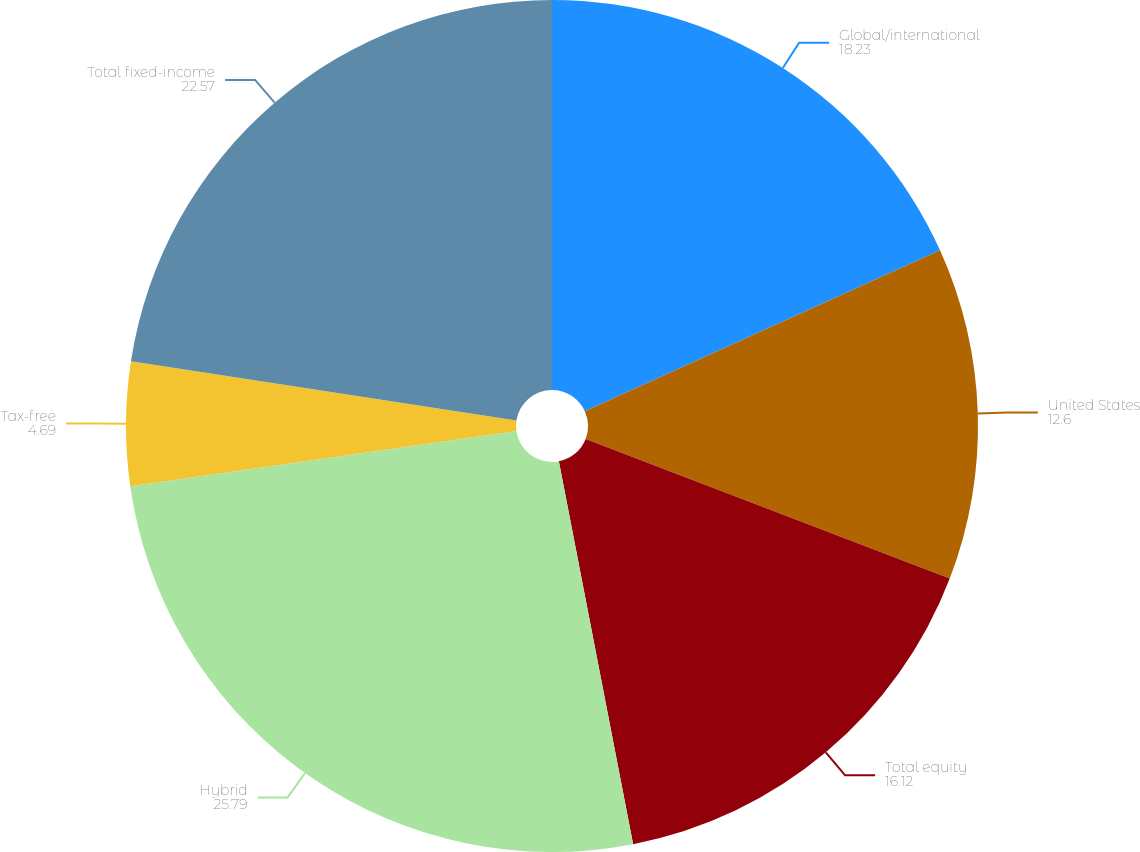Convert chart. <chart><loc_0><loc_0><loc_500><loc_500><pie_chart><fcel>Global/international<fcel>United States<fcel>Total equity<fcel>Hybrid<fcel>Tax-free<fcel>Total fixed-income<nl><fcel>18.23%<fcel>12.6%<fcel>16.12%<fcel>25.79%<fcel>4.69%<fcel>22.57%<nl></chart> 